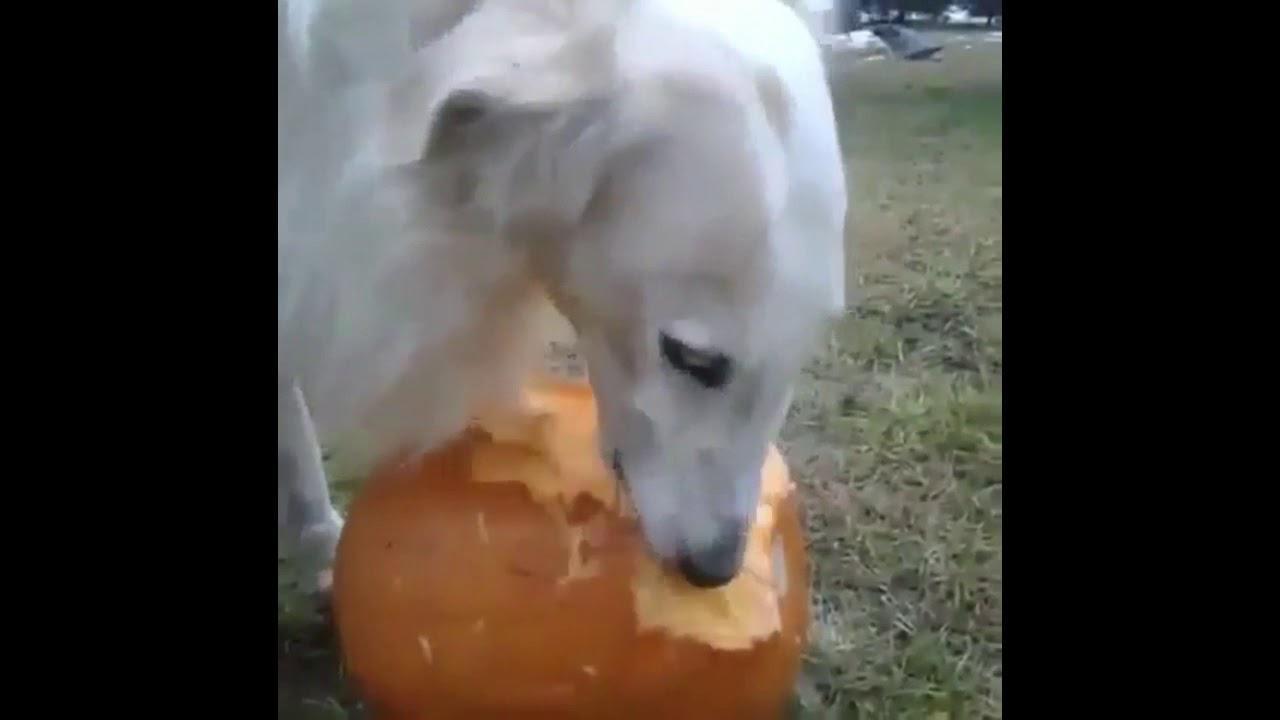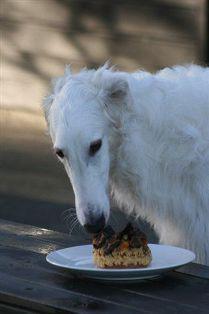The first image is the image on the left, the second image is the image on the right. Examine the images to the left and right. Is the description "There are two dogs with long noses eating food." accurate? Answer yes or no. Yes. The first image is the image on the left, the second image is the image on the right. For the images displayed, is the sentence "One image shows a dog being hand fed." factually correct? Answer yes or no. No. 